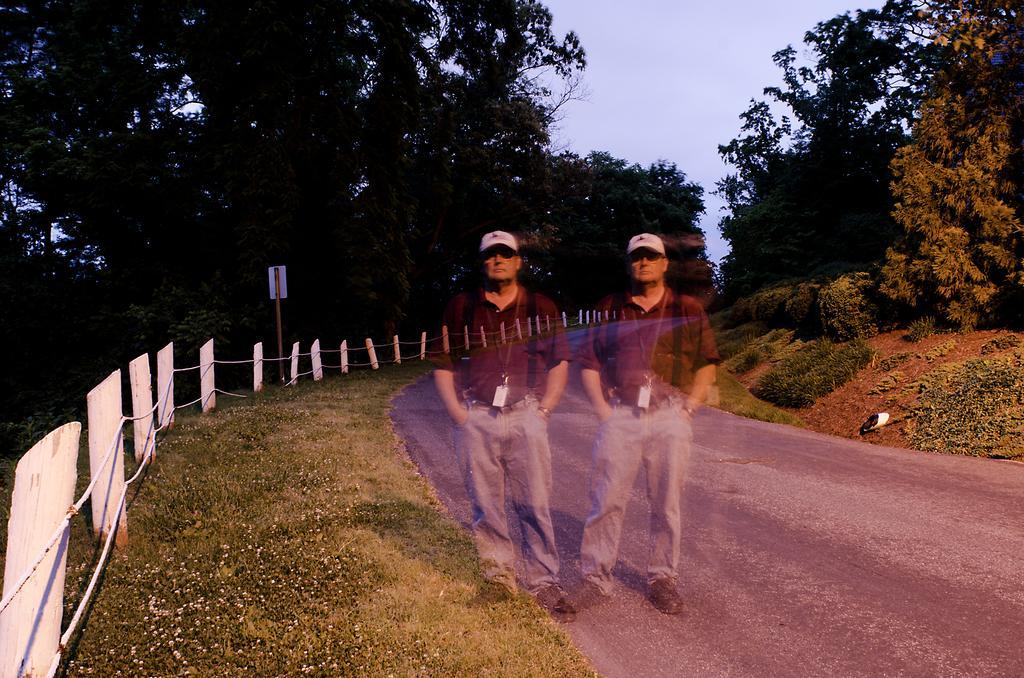Please provide a concise description of this image. In the image there are two men standing on the side of the road with same t-shirt,pant and cap, on left side there is fence beside grass land, on either side of the road there are trees all over the place and above its sky. 